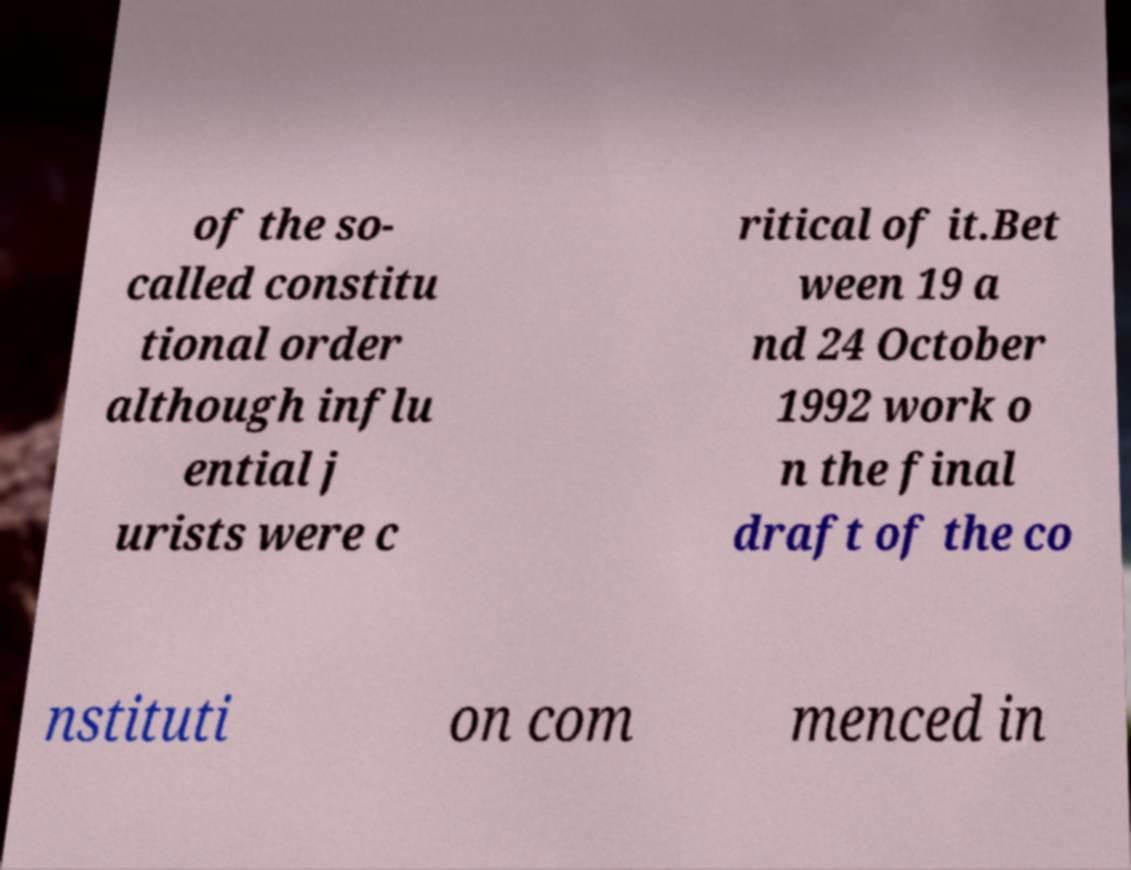There's text embedded in this image that I need extracted. Can you transcribe it verbatim? of the so- called constitu tional order although influ ential j urists were c ritical of it.Bet ween 19 a nd 24 October 1992 work o n the final draft of the co nstituti on com menced in 